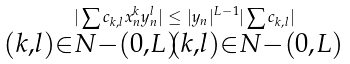Convert formula to latex. <formula><loc_0><loc_0><loc_500><loc_500>| \sum _ { \mathclap { ( k , l ) \in N - ( 0 , L ) } } c _ { k , l } x _ { n } ^ { k } y _ { n } ^ { l } | \leq | y _ { n } | ^ { L - 1 } | \sum _ { \mathclap { ( k , l ) \in N - ( 0 , L ) } } c _ { k , l } |</formula> 